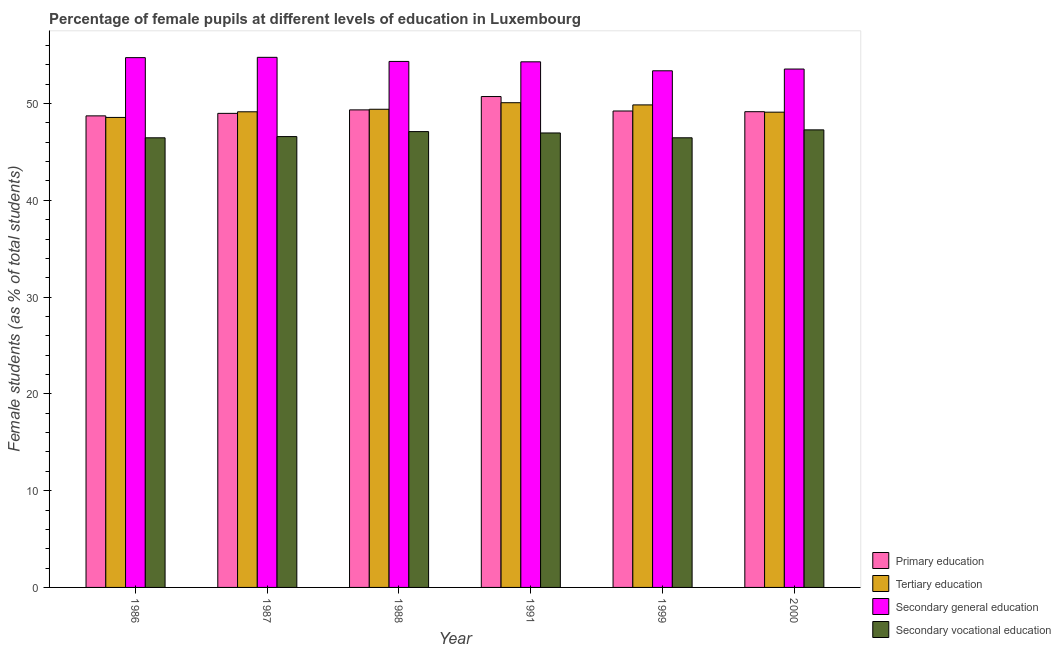Are the number of bars on each tick of the X-axis equal?
Provide a succinct answer. Yes. How many bars are there on the 5th tick from the left?
Your answer should be compact. 4. What is the label of the 3rd group of bars from the left?
Ensure brevity in your answer.  1988. What is the percentage of female students in primary education in 2000?
Keep it short and to the point. 49.16. Across all years, what is the maximum percentage of female students in tertiary education?
Ensure brevity in your answer.  50.08. Across all years, what is the minimum percentage of female students in secondary education?
Provide a succinct answer. 53.38. What is the total percentage of female students in secondary education in the graph?
Give a very brief answer. 325.12. What is the difference between the percentage of female students in primary education in 1988 and that in 2000?
Give a very brief answer. 0.19. What is the difference between the percentage of female students in secondary vocational education in 1986 and the percentage of female students in tertiary education in 1999?
Provide a short and direct response. -0. What is the average percentage of female students in secondary education per year?
Offer a very short reply. 54.19. In the year 1986, what is the difference between the percentage of female students in secondary vocational education and percentage of female students in tertiary education?
Make the answer very short. 0. What is the ratio of the percentage of female students in tertiary education in 1986 to that in 1991?
Provide a succinct answer. 0.97. What is the difference between the highest and the second highest percentage of female students in tertiary education?
Provide a succinct answer. 0.23. What is the difference between the highest and the lowest percentage of female students in secondary education?
Offer a very short reply. 1.39. In how many years, is the percentage of female students in secondary vocational education greater than the average percentage of female students in secondary vocational education taken over all years?
Give a very brief answer. 3. What does the 4th bar from the left in 1991 represents?
Make the answer very short. Secondary vocational education. What does the 3rd bar from the right in 1999 represents?
Make the answer very short. Tertiary education. Are all the bars in the graph horizontal?
Offer a very short reply. No. Does the graph contain any zero values?
Provide a succinct answer. No. Does the graph contain grids?
Offer a terse response. No. Where does the legend appear in the graph?
Provide a short and direct response. Bottom right. How many legend labels are there?
Your response must be concise. 4. What is the title of the graph?
Your answer should be compact. Percentage of female pupils at different levels of education in Luxembourg. What is the label or title of the X-axis?
Keep it short and to the point. Year. What is the label or title of the Y-axis?
Provide a short and direct response. Female students (as % of total students). What is the Female students (as % of total students) of Primary education in 1986?
Make the answer very short. 48.73. What is the Female students (as % of total students) in Tertiary education in 1986?
Your answer should be compact. 48.56. What is the Female students (as % of total students) of Secondary general education in 1986?
Give a very brief answer. 54.74. What is the Female students (as % of total students) in Secondary vocational education in 1986?
Make the answer very short. 46.46. What is the Female students (as % of total students) of Primary education in 1987?
Provide a succinct answer. 48.98. What is the Female students (as % of total students) of Tertiary education in 1987?
Provide a short and direct response. 49.15. What is the Female students (as % of total students) of Secondary general education in 1987?
Your answer should be very brief. 54.77. What is the Female students (as % of total students) in Secondary vocational education in 1987?
Make the answer very short. 46.58. What is the Female students (as % of total students) of Primary education in 1988?
Provide a succinct answer. 49.34. What is the Female students (as % of total students) in Tertiary education in 1988?
Your response must be concise. 49.41. What is the Female students (as % of total students) of Secondary general education in 1988?
Keep it short and to the point. 54.35. What is the Female students (as % of total students) in Secondary vocational education in 1988?
Offer a very short reply. 47.1. What is the Female students (as % of total students) in Primary education in 1991?
Your response must be concise. 50.72. What is the Female students (as % of total students) in Tertiary education in 1991?
Your response must be concise. 50.08. What is the Female students (as % of total students) of Secondary general education in 1991?
Your response must be concise. 54.31. What is the Female students (as % of total students) in Secondary vocational education in 1991?
Provide a short and direct response. 46.96. What is the Female students (as % of total students) of Primary education in 1999?
Your response must be concise. 49.23. What is the Female students (as % of total students) in Tertiary education in 1999?
Your response must be concise. 49.86. What is the Female students (as % of total students) in Secondary general education in 1999?
Provide a short and direct response. 53.38. What is the Female students (as % of total students) of Secondary vocational education in 1999?
Provide a short and direct response. 46.46. What is the Female students (as % of total students) of Primary education in 2000?
Your answer should be very brief. 49.16. What is the Female students (as % of total students) of Tertiary education in 2000?
Provide a short and direct response. 49.11. What is the Female students (as % of total students) of Secondary general education in 2000?
Provide a short and direct response. 53.56. What is the Female students (as % of total students) of Secondary vocational education in 2000?
Your answer should be very brief. 47.28. Across all years, what is the maximum Female students (as % of total students) of Primary education?
Provide a succinct answer. 50.72. Across all years, what is the maximum Female students (as % of total students) in Tertiary education?
Your answer should be very brief. 50.08. Across all years, what is the maximum Female students (as % of total students) of Secondary general education?
Give a very brief answer. 54.77. Across all years, what is the maximum Female students (as % of total students) in Secondary vocational education?
Your answer should be very brief. 47.28. Across all years, what is the minimum Female students (as % of total students) of Primary education?
Your answer should be compact. 48.73. Across all years, what is the minimum Female students (as % of total students) in Tertiary education?
Your response must be concise. 48.56. Across all years, what is the minimum Female students (as % of total students) of Secondary general education?
Offer a terse response. 53.38. Across all years, what is the minimum Female students (as % of total students) of Secondary vocational education?
Ensure brevity in your answer.  46.46. What is the total Female students (as % of total students) of Primary education in the graph?
Provide a succinct answer. 296.16. What is the total Female students (as % of total students) in Tertiary education in the graph?
Provide a short and direct response. 296.17. What is the total Female students (as % of total students) in Secondary general education in the graph?
Offer a very short reply. 325.12. What is the total Female students (as % of total students) of Secondary vocational education in the graph?
Provide a succinct answer. 280.84. What is the difference between the Female students (as % of total students) in Primary education in 1986 and that in 1987?
Make the answer very short. -0.26. What is the difference between the Female students (as % of total students) in Tertiary education in 1986 and that in 1987?
Give a very brief answer. -0.58. What is the difference between the Female students (as % of total students) in Secondary general education in 1986 and that in 1987?
Your answer should be very brief. -0.03. What is the difference between the Female students (as % of total students) of Secondary vocational education in 1986 and that in 1987?
Offer a very short reply. -0.13. What is the difference between the Female students (as % of total students) of Primary education in 1986 and that in 1988?
Keep it short and to the point. -0.62. What is the difference between the Female students (as % of total students) of Tertiary education in 1986 and that in 1988?
Your answer should be compact. -0.84. What is the difference between the Female students (as % of total students) of Secondary general education in 1986 and that in 1988?
Ensure brevity in your answer.  0.39. What is the difference between the Female students (as % of total students) in Secondary vocational education in 1986 and that in 1988?
Keep it short and to the point. -0.64. What is the difference between the Female students (as % of total students) in Primary education in 1986 and that in 1991?
Provide a succinct answer. -2. What is the difference between the Female students (as % of total students) of Tertiary education in 1986 and that in 1991?
Your response must be concise. -1.52. What is the difference between the Female students (as % of total students) in Secondary general education in 1986 and that in 1991?
Keep it short and to the point. 0.43. What is the difference between the Female students (as % of total students) in Secondary vocational education in 1986 and that in 1991?
Your answer should be very brief. -0.5. What is the difference between the Female students (as % of total students) in Primary education in 1986 and that in 1999?
Your answer should be very brief. -0.5. What is the difference between the Female students (as % of total students) in Tertiary education in 1986 and that in 1999?
Provide a succinct answer. -1.29. What is the difference between the Female students (as % of total students) in Secondary general education in 1986 and that in 1999?
Offer a very short reply. 1.36. What is the difference between the Female students (as % of total students) of Secondary vocational education in 1986 and that in 1999?
Make the answer very short. -0. What is the difference between the Female students (as % of total students) of Primary education in 1986 and that in 2000?
Ensure brevity in your answer.  -0.43. What is the difference between the Female students (as % of total students) of Tertiary education in 1986 and that in 2000?
Offer a terse response. -0.55. What is the difference between the Female students (as % of total students) in Secondary general education in 1986 and that in 2000?
Offer a very short reply. 1.18. What is the difference between the Female students (as % of total students) of Secondary vocational education in 1986 and that in 2000?
Offer a very short reply. -0.82. What is the difference between the Female students (as % of total students) in Primary education in 1987 and that in 1988?
Provide a succinct answer. -0.36. What is the difference between the Female students (as % of total students) of Tertiary education in 1987 and that in 1988?
Ensure brevity in your answer.  -0.26. What is the difference between the Female students (as % of total students) in Secondary general education in 1987 and that in 1988?
Your answer should be very brief. 0.42. What is the difference between the Female students (as % of total students) in Secondary vocational education in 1987 and that in 1988?
Provide a succinct answer. -0.51. What is the difference between the Female students (as % of total students) of Primary education in 1987 and that in 1991?
Your response must be concise. -1.74. What is the difference between the Female students (as % of total students) of Tertiary education in 1987 and that in 1991?
Provide a succinct answer. -0.94. What is the difference between the Female students (as % of total students) of Secondary general education in 1987 and that in 1991?
Make the answer very short. 0.46. What is the difference between the Female students (as % of total students) in Secondary vocational education in 1987 and that in 1991?
Ensure brevity in your answer.  -0.37. What is the difference between the Female students (as % of total students) in Primary education in 1987 and that in 1999?
Ensure brevity in your answer.  -0.25. What is the difference between the Female students (as % of total students) of Tertiary education in 1987 and that in 1999?
Your answer should be very brief. -0.71. What is the difference between the Female students (as % of total students) of Secondary general education in 1987 and that in 1999?
Provide a short and direct response. 1.39. What is the difference between the Female students (as % of total students) in Secondary vocational education in 1987 and that in 1999?
Your answer should be compact. 0.12. What is the difference between the Female students (as % of total students) in Primary education in 1987 and that in 2000?
Your answer should be compact. -0.17. What is the difference between the Female students (as % of total students) in Tertiary education in 1987 and that in 2000?
Provide a short and direct response. 0.04. What is the difference between the Female students (as % of total students) in Secondary general education in 1987 and that in 2000?
Your answer should be compact. 1.21. What is the difference between the Female students (as % of total students) in Secondary vocational education in 1987 and that in 2000?
Offer a very short reply. -0.69. What is the difference between the Female students (as % of total students) of Primary education in 1988 and that in 1991?
Your response must be concise. -1.38. What is the difference between the Female students (as % of total students) in Tertiary education in 1988 and that in 1991?
Make the answer very short. -0.68. What is the difference between the Female students (as % of total students) in Secondary general education in 1988 and that in 1991?
Offer a very short reply. 0.04. What is the difference between the Female students (as % of total students) in Secondary vocational education in 1988 and that in 1991?
Your answer should be compact. 0.14. What is the difference between the Female students (as % of total students) in Primary education in 1988 and that in 1999?
Offer a very short reply. 0.11. What is the difference between the Female students (as % of total students) of Tertiary education in 1988 and that in 1999?
Give a very brief answer. -0.45. What is the difference between the Female students (as % of total students) of Secondary general education in 1988 and that in 1999?
Your answer should be compact. 0.97. What is the difference between the Female students (as % of total students) of Secondary vocational education in 1988 and that in 1999?
Provide a short and direct response. 0.64. What is the difference between the Female students (as % of total students) in Primary education in 1988 and that in 2000?
Keep it short and to the point. 0.19. What is the difference between the Female students (as % of total students) in Tertiary education in 1988 and that in 2000?
Your answer should be very brief. 0.3. What is the difference between the Female students (as % of total students) of Secondary general education in 1988 and that in 2000?
Your answer should be very brief. 0.79. What is the difference between the Female students (as % of total students) in Secondary vocational education in 1988 and that in 2000?
Ensure brevity in your answer.  -0.18. What is the difference between the Female students (as % of total students) of Primary education in 1991 and that in 1999?
Offer a very short reply. 1.49. What is the difference between the Female students (as % of total students) in Tertiary education in 1991 and that in 1999?
Provide a short and direct response. 0.23. What is the difference between the Female students (as % of total students) of Secondary general education in 1991 and that in 1999?
Keep it short and to the point. 0.93. What is the difference between the Female students (as % of total students) of Secondary vocational education in 1991 and that in 1999?
Offer a terse response. 0.5. What is the difference between the Female students (as % of total students) in Primary education in 1991 and that in 2000?
Your answer should be compact. 1.57. What is the difference between the Female students (as % of total students) of Tertiary education in 1991 and that in 2000?
Offer a terse response. 0.98. What is the difference between the Female students (as % of total students) in Secondary general education in 1991 and that in 2000?
Offer a terse response. 0.75. What is the difference between the Female students (as % of total students) of Secondary vocational education in 1991 and that in 2000?
Provide a succinct answer. -0.32. What is the difference between the Female students (as % of total students) in Primary education in 1999 and that in 2000?
Your answer should be very brief. 0.07. What is the difference between the Female students (as % of total students) of Tertiary education in 1999 and that in 2000?
Offer a terse response. 0.75. What is the difference between the Female students (as % of total students) of Secondary general education in 1999 and that in 2000?
Provide a succinct answer. -0.18. What is the difference between the Female students (as % of total students) in Secondary vocational education in 1999 and that in 2000?
Provide a succinct answer. -0.82. What is the difference between the Female students (as % of total students) of Primary education in 1986 and the Female students (as % of total students) of Tertiary education in 1987?
Your answer should be very brief. -0.42. What is the difference between the Female students (as % of total students) in Primary education in 1986 and the Female students (as % of total students) in Secondary general education in 1987?
Provide a short and direct response. -6.05. What is the difference between the Female students (as % of total students) of Primary education in 1986 and the Female students (as % of total students) of Secondary vocational education in 1987?
Your answer should be very brief. 2.14. What is the difference between the Female students (as % of total students) of Tertiary education in 1986 and the Female students (as % of total students) of Secondary general education in 1987?
Provide a short and direct response. -6.21. What is the difference between the Female students (as % of total students) in Tertiary education in 1986 and the Female students (as % of total students) in Secondary vocational education in 1987?
Your answer should be very brief. 1.98. What is the difference between the Female students (as % of total students) of Secondary general education in 1986 and the Female students (as % of total students) of Secondary vocational education in 1987?
Keep it short and to the point. 8.16. What is the difference between the Female students (as % of total students) in Primary education in 1986 and the Female students (as % of total students) in Tertiary education in 1988?
Offer a terse response. -0.68. What is the difference between the Female students (as % of total students) in Primary education in 1986 and the Female students (as % of total students) in Secondary general education in 1988?
Offer a terse response. -5.62. What is the difference between the Female students (as % of total students) in Primary education in 1986 and the Female students (as % of total students) in Secondary vocational education in 1988?
Make the answer very short. 1.63. What is the difference between the Female students (as % of total students) of Tertiary education in 1986 and the Female students (as % of total students) of Secondary general education in 1988?
Keep it short and to the point. -5.79. What is the difference between the Female students (as % of total students) in Tertiary education in 1986 and the Female students (as % of total students) in Secondary vocational education in 1988?
Keep it short and to the point. 1.46. What is the difference between the Female students (as % of total students) of Secondary general education in 1986 and the Female students (as % of total students) of Secondary vocational education in 1988?
Keep it short and to the point. 7.64. What is the difference between the Female students (as % of total students) of Primary education in 1986 and the Female students (as % of total students) of Tertiary education in 1991?
Give a very brief answer. -1.36. What is the difference between the Female students (as % of total students) in Primary education in 1986 and the Female students (as % of total students) in Secondary general education in 1991?
Ensure brevity in your answer.  -5.58. What is the difference between the Female students (as % of total students) of Primary education in 1986 and the Female students (as % of total students) of Secondary vocational education in 1991?
Give a very brief answer. 1.77. What is the difference between the Female students (as % of total students) of Tertiary education in 1986 and the Female students (as % of total students) of Secondary general education in 1991?
Provide a succinct answer. -5.75. What is the difference between the Female students (as % of total students) in Tertiary education in 1986 and the Female students (as % of total students) in Secondary vocational education in 1991?
Offer a terse response. 1.6. What is the difference between the Female students (as % of total students) of Secondary general education in 1986 and the Female students (as % of total students) of Secondary vocational education in 1991?
Offer a very short reply. 7.78. What is the difference between the Female students (as % of total students) of Primary education in 1986 and the Female students (as % of total students) of Tertiary education in 1999?
Provide a succinct answer. -1.13. What is the difference between the Female students (as % of total students) in Primary education in 1986 and the Female students (as % of total students) in Secondary general education in 1999?
Ensure brevity in your answer.  -4.66. What is the difference between the Female students (as % of total students) of Primary education in 1986 and the Female students (as % of total students) of Secondary vocational education in 1999?
Offer a very short reply. 2.27. What is the difference between the Female students (as % of total students) of Tertiary education in 1986 and the Female students (as % of total students) of Secondary general education in 1999?
Keep it short and to the point. -4.82. What is the difference between the Female students (as % of total students) of Tertiary education in 1986 and the Female students (as % of total students) of Secondary vocational education in 1999?
Ensure brevity in your answer.  2.1. What is the difference between the Female students (as % of total students) in Secondary general education in 1986 and the Female students (as % of total students) in Secondary vocational education in 1999?
Your answer should be very brief. 8.28. What is the difference between the Female students (as % of total students) in Primary education in 1986 and the Female students (as % of total students) in Tertiary education in 2000?
Offer a terse response. -0.38. What is the difference between the Female students (as % of total students) of Primary education in 1986 and the Female students (as % of total students) of Secondary general education in 2000?
Give a very brief answer. -4.84. What is the difference between the Female students (as % of total students) of Primary education in 1986 and the Female students (as % of total students) of Secondary vocational education in 2000?
Your response must be concise. 1.45. What is the difference between the Female students (as % of total students) in Tertiary education in 1986 and the Female students (as % of total students) in Secondary general education in 2000?
Your answer should be very brief. -5. What is the difference between the Female students (as % of total students) of Tertiary education in 1986 and the Female students (as % of total students) of Secondary vocational education in 2000?
Give a very brief answer. 1.28. What is the difference between the Female students (as % of total students) of Secondary general education in 1986 and the Female students (as % of total students) of Secondary vocational education in 2000?
Ensure brevity in your answer.  7.46. What is the difference between the Female students (as % of total students) in Primary education in 1987 and the Female students (as % of total students) in Tertiary education in 1988?
Your response must be concise. -0.42. What is the difference between the Female students (as % of total students) in Primary education in 1987 and the Female students (as % of total students) in Secondary general education in 1988?
Offer a terse response. -5.37. What is the difference between the Female students (as % of total students) in Primary education in 1987 and the Female students (as % of total students) in Secondary vocational education in 1988?
Your answer should be very brief. 1.88. What is the difference between the Female students (as % of total students) of Tertiary education in 1987 and the Female students (as % of total students) of Secondary general education in 1988?
Your answer should be very brief. -5.2. What is the difference between the Female students (as % of total students) of Tertiary education in 1987 and the Female students (as % of total students) of Secondary vocational education in 1988?
Make the answer very short. 2.05. What is the difference between the Female students (as % of total students) in Secondary general education in 1987 and the Female students (as % of total students) in Secondary vocational education in 1988?
Your answer should be compact. 7.67. What is the difference between the Female students (as % of total students) of Primary education in 1987 and the Female students (as % of total students) of Tertiary education in 1991?
Ensure brevity in your answer.  -1.1. What is the difference between the Female students (as % of total students) in Primary education in 1987 and the Female students (as % of total students) in Secondary general education in 1991?
Ensure brevity in your answer.  -5.33. What is the difference between the Female students (as % of total students) of Primary education in 1987 and the Female students (as % of total students) of Secondary vocational education in 1991?
Your answer should be very brief. 2.02. What is the difference between the Female students (as % of total students) of Tertiary education in 1987 and the Female students (as % of total students) of Secondary general education in 1991?
Make the answer very short. -5.16. What is the difference between the Female students (as % of total students) in Tertiary education in 1987 and the Female students (as % of total students) in Secondary vocational education in 1991?
Offer a very short reply. 2.19. What is the difference between the Female students (as % of total students) in Secondary general education in 1987 and the Female students (as % of total students) in Secondary vocational education in 1991?
Your answer should be very brief. 7.81. What is the difference between the Female students (as % of total students) of Primary education in 1987 and the Female students (as % of total students) of Tertiary education in 1999?
Your answer should be very brief. -0.88. What is the difference between the Female students (as % of total students) in Primary education in 1987 and the Female students (as % of total students) in Secondary general education in 1999?
Keep it short and to the point. -4.4. What is the difference between the Female students (as % of total students) of Primary education in 1987 and the Female students (as % of total students) of Secondary vocational education in 1999?
Your response must be concise. 2.52. What is the difference between the Female students (as % of total students) in Tertiary education in 1987 and the Female students (as % of total students) in Secondary general education in 1999?
Provide a short and direct response. -4.24. What is the difference between the Female students (as % of total students) in Tertiary education in 1987 and the Female students (as % of total students) in Secondary vocational education in 1999?
Your response must be concise. 2.69. What is the difference between the Female students (as % of total students) of Secondary general education in 1987 and the Female students (as % of total students) of Secondary vocational education in 1999?
Your answer should be compact. 8.31. What is the difference between the Female students (as % of total students) in Primary education in 1987 and the Female students (as % of total students) in Tertiary education in 2000?
Make the answer very short. -0.13. What is the difference between the Female students (as % of total students) of Primary education in 1987 and the Female students (as % of total students) of Secondary general education in 2000?
Ensure brevity in your answer.  -4.58. What is the difference between the Female students (as % of total students) in Primary education in 1987 and the Female students (as % of total students) in Secondary vocational education in 2000?
Your answer should be very brief. 1.7. What is the difference between the Female students (as % of total students) in Tertiary education in 1987 and the Female students (as % of total students) in Secondary general education in 2000?
Your answer should be compact. -4.42. What is the difference between the Female students (as % of total students) of Tertiary education in 1987 and the Female students (as % of total students) of Secondary vocational education in 2000?
Offer a terse response. 1.87. What is the difference between the Female students (as % of total students) of Secondary general education in 1987 and the Female students (as % of total students) of Secondary vocational education in 2000?
Offer a very short reply. 7.5. What is the difference between the Female students (as % of total students) in Primary education in 1988 and the Female students (as % of total students) in Tertiary education in 1991?
Your response must be concise. -0.74. What is the difference between the Female students (as % of total students) of Primary education in 1988 and the Female students (as % of total students) of Secondary general education in 1991?
Your response must be concise. -4.96. What is the difference between the Female students (as % of total students) of Primary education in 1988 and the Female students (as % of total students) of Secondary vocational education in 1991?
Ensure brevity in your answer.  2.39. What is the difference between the Female students (as % of total students) in Tertiary education in 1988 and the Female students (as % of total students) in Secondary general education in 1991?
Provide a short and direct response. -4.9. What is the difference between the Female students (as % of total students) in Tertiary education in 1988 and the Female students (as % of total students) in Secondary vocational education in 1991?
Provide a short and direct response. 2.45. What is the difference between the Female students (as % of total students) in Secondary general education in 1988 and the Female students (as % of total students) in Secondary vocational education in 1991?
Ensure brevity in your answer.  7.39. What is the difference between the Female students (as % of total students) of Primary education in 1988 and the Female students (as % of total students) of Tertiary education in 1999?
Keep it short and to the point. -0.51. What is the difference between the Female students (as % of total students) of Primary education in 1988 and the Female students (as % of total students) of Secondary general education in 1999?
Offer a very short reply. -4.04. What is the difference between the Female students (as % of total students) of Primary education in 1988 and the Female students (as % of total students) of Secondary vocational education in 1999?
Keep it short and to the point. 2.88. What is the difference between the Female students (as % of total students) in Tertiary education in 1988 and the Female students (as % of total students) in Secondary general education in 1999?
Your answer should be compact. -3.97. What is the difference between the Female students (as % of total students) of Tertiary education in 1988 and the Female students (as % of total students) of Secondary vocational education in 1999?
Your answer should be very brief. 2.95. What is the difference between the Female students (as % of total students) of Secondary general education in 1988 and the Female students (as % of total students) of Secondary vocational education in 1999?
Your response must be concise. 7.89. What is the difference between the Female students (as % of total students) in Primary education in 1988 and the Female students (as % of total students) in Tertiary education in 2000?
Provide a short and direct response. 0.24. What is the difference between the Female students (as % of total students) of Primary education in 1988 and the Female students (as % of total students) of Secondary general education in 2000?
Make the answer very short. -4.22. What is the difference between the Female students (as % of total students) of Primary education in 1988 and the Female students (as % of total students) of Secondary vocational education in 2000?
Offer a very short reply. 2.07. What is the difference between the Female students (as % of total students) of Tertiary education in 1988 and the Female students (as % of total students) of Secondary general education in 2000?
Keep it short and to the point. -4.16. What is the difference between the Female students (as % of total students) in Tertiary education in 1988 and the Female students (as % of total students) in Secondary vocational education in 2000?
Your answer should be compact. 2.13. What is the difference between the Female students (as % of total students) of Secondary general education in 1988 and the Female students (as % of total students) of Secondary vocational education in 2000?
Provide a short and direct response. 7.07. What is the difference between the Female students (as % of total students) of Primary education in 1991 and the Female students (as % of total students) of Tertiary education in 1999?
Keep it short and to the point. 0.86. What is the difference between the Female students (as % of total students) in Primary education in 1991 and the Female students (as % of total students) in Secondary general education in 1999?
Offer a terse response. -2.66. What is the difference between the Female students (as % of total students) of Primary education in 1991 and the Female students (as % of total students) of Secondary vocational education in 1999?
Ensure brevity in your answer.  4.26. What is the difference between the Female students (as % of total students) in Tertiary education in 1991 and the Female students (as % of total students) in Secondary general education in 1999?
Your answer should be compact. -3.3. What is the difference between the Female students (as % of total students) in Tertiary education in 1991 and the Female students (as % of total students) in Secondary vocational education in 1999?
Provide a short and direct response. 3.62. What is the difference between the Female students (as % of total students) in Secondary general education in 1991 and the Female students (as % of total students) in Secondary vocational education in 1999?
Provide a succinct answer. 7.85. What is the difference between the Female students (as % of total students) of Primary education in 1991 and the Female students (as % of total students) of Tertiary education in 2000?
Your response must be concise. 1.61. What is the difference between the Female students (as % of total students) of Primary education in 1991 and the Female students (as % of total students) of Secondary general education in 2000?
Your response must be concise. -2.84. What is the difference between the Female students (as % of total students) in Primary education in 1991 and the Female students (as % of total students) in Secondary vocational education in 2000?
Make the answer very short. 3.44. What is the difference between the Female students (as % of total students) in Tertiary education in 1991 and the Female students (as % of total students) in Secondary general education in 2000?
Give a very brief answer. -3.48. What is the difference between the Female students (as % of total students) in Tertiary education in 1991 and the Female students (as % of total students) in Secondary vocational education in 2000?
Keep it short and to the point. 2.81. What is the difference between the Female students (as % of total students) in Secondary general education in 1991 and the Female students (as % of total students) in Secondary vocational education in 2000?
Make the answer very short. 7.03. What is the difference between the Female students (as % of total students) of Primary education in 1999 and the Female students (as % of total students) of Tertiary education in 2000?
Make the answer very short. 0.12. What is the difference between the Female students (as % of total students) in Primary education in 1999 and the Female students (as % of total students) in Secondary general education in 2000?
Provide a short and direct response. -4.33. What is the difference between the Female students (as % of total students) of Primary education in 1999 and the Female students (as % of total students) of Secondary vocational education in 2000?
Give a very brief answer. 1.95. What is the difference between the Female students (as % of total students) in Tertiary education in 1999 and the Female students (as % of total students) in Secondary general education in 2000?
Your response must be concise. -3.71. What is the difference between the Female students (as % of total students) of Tertiary education in 1999 and the Female students (as % of total students) of Secondary vocational education in 2000?
Provide a succinct answer. 2.58. What is the difference between the Female students (as % of total students) of Secondary general education in 1999 and the Female students (as % of total students) of Secondary vocational education in 2000?
Offer a terse response. 6.1. What is the average Female students (as % of total students) of Primary education per year?
Give a very brief answer. 49.36. What is the average Female students (as % of total students) in Tertiary education per year?
Provide a succinct answer. 49.36. What is the average Female students (as % of total students) in Secondary general education per year?
Give a very brief answer. 54.19. What is the average Female students (as % of total students) in Secondary vocational education per year?
Offer a terse response. 46.81. In the year 1986, what is the difference between the Female students (as % of total students) of Primary education and Female students (as % of total students) of Tertiary education?
Make the answer very short. 0.16. In the year 1986, what is the difference between the Female students (as % of total students) in Primary education and Female students (as % of total students) in Secondary general education?
Your answer should be very brief. -6.02. In the year 1986, what is the difference between the Female students (as % of total students) of Primary education and Female students (as % of total students) of Secondary vocational education?
Give a very brief answer. 2.27. In the year 1986, what is the difference between the Female students (as % of total students) of Tertiary education and Female students (as % of total students) of Secondary general education?
Your answer should be very brief. -6.18. In the year 1986, what is the difference between the Female students (as % of total students) of Tertiary education and Female students (as % of total students) of Secondary vocational education?
Give a very brief answer. 2.11. In the year 1986, what is the difference between the Female students (as % of total students) in Secondary general education and Female students (as % of total students) in Secondary vocational education?
Your answer should be very brief. 8.28. In the year 1987, what is the difference between the Female students (as % of total students) of Primary education and Female students (as % of total students) of Tertiary education?
Your answer should be compact. -0.16. In the year 1987, what is the difference between the Female students (as % of total students) of Primary education and Female students (as % of total students) of Secondary general education?
Make the answer very short. -5.79. In the year 1987, what is the difference between the Female students (as % of total students) of Primary education and Female students (as % of total students) of Secondary vocational education?
Your answer should be compact. 2.4. In the year 1987, what is the difference between the Female students (as % of total students) of Tertiary education and Female students (as % of total students) of Secondary general education?
Your answer should be very brief. -5.63. In the year 1987, what is the difference between the Female students (as % of total students) of Tertiary education and Female students (as % of total students) of Secondary vocational education?
Give a very brief answer. 2.56. In the year 1987, what is the difference between the Female students (as % of total students) of Secondary general education and Female students (as % of total students) of Secondary vocational education?
Your answer should be compact. 8.19. In the year 1988, what is the difference between the Female students (as % of total students) in Primary education and Female students (as % of total students) in Tertiary education?
Provide a succinct answer. -0.06. In the year 1988, what is the difference between the Female students (as % of total students) of Primary education and Female students (as % of total students) of Secondary general education?
Make the answer very short. -5.01. In the year 1988, what is the difference between the Female students (as % of total students) in Primary education and Female students (as % of total students) in Secondary vocational education?
Your answer should be very brief. 2.24. In the year 1988, what is the difference between the Female students (as % of total students) of Tertiary education and Female students (as % of total students) of Secondary general education?
Provide a succinct answer. -4.94. In the year 1988, what is the difference between the Female students (as % of total students) in Tertiary education and Female students (as % of total students) in Secondary vocational education?
Your response must be concise. 2.31. In the year 1988, what is the difference between the Female students (as % of total students) in Secondary general education and Female students (as % of total students) in Secondary vocational education?
Provide a succinct answer. 7.25. In the year 1991, what is the difference between the Female students (as % of total students) in Primary education and Female students (as % of total students) in Tertiary education?
Provide a short and direct response. 0.64. In the year 1991, what is the difference between the Female students (as % of total students) of Primary education and Female students (as % of total students) of Secondary general education?
Ensure brevity in your answer.  -3.59. In the year 1991, what is the difference between the Female students (as % of total students) of Primary education and Female students (as % of total students) of Secondary vocational education?
Keep it short and to the point. 3.76. In the year 1991, what is the difference between the Female students (as % of total students) of Tertiary education and Female students (as % of total students) of Secondary general education?
Give a very brief answer. -4.22. In the year 1991, what is the difference between the Female students (as % of total students) in Tertiary education and Female students (as % of total students) in Secondary vocational education?
Offer a terse response. 3.13. In the year 1991, what is the difference between the Female students (as % of total students) in Secondary general education and Female students (as % of total students) in Secondary vocational education?
Your answer should be compact. 7.35. In the year 1999, what is the difference between the Female students (as % of total students) in Primary education and Female students (as % of total students) in Tertiary education?
Give a very brief answer. -0.63. In the year 1999, what is the difference between the Female students (as % of total students) in Primary education and Female students (as % of total students) in Secondary general education?
Make the answer very short. -4.15. In the year 1999, what is the difference between the Female students (as % of total students) of Primary education and Female students (as % of total students) of Secondary vocational education?
Keep it short and to the point. 2.77. In the year 1999, what is the difference between the Female students (as % of total students) in Tertiary education and Female students (as % of total students) in Secondary general education?
Ensure brevity in your answer.  -3.52. In the year 1999, what is the difference between the Female students (as % of total students) of Tertiary education and Female students (as % of total students) of Secondary vocational education?
Ensure brevity in your answer.  3.4. In the year 1999, what is the difference between the Female students (as % of total students) of Secondary general education and Female students (as % of total students) of Secondary vocational education?
Make the answer very short. 6.92. In the year 2000, what is the difference between the Female students (as % of total students) of Primary education and Female students (as % of total students) of Tertiary education?
Ensure brevity in your answer.  0.05. In the year 2000, what is the difference between the Female students (as % of total students) of Primary education and Female students (as % of total students) of Secondary general education?
Keep it short and to the point. -4.41. In the year 2000, what is the difference between the Female students (as % of total students) of Primary education and Female students (as % of total students) of Secondary vocational education?
Your response must be concise. 1.88. In the year 2000, what is the difference between the Female students (as % of total students) in Tertiary education and Female students (as % of total students) in Secondary general education?
Offer a very short reply. -4.46. In the year 2000, what is the difference between the Female students (as % of total students) in Tertiary education and Female students (as % of total students) in Secondary vocational education?
Provide a short and direct response. 1.83. In the year 2000, what is the difference between the Female students (as % of total students) in Secondary general education and Female students (as % of total students) in Secondary vocational education?
Provide a succinct answer. 6.29. What is the ratio of the Female students (as % of total students) in Tertiary education in 1986 to that in 1987?
Provide a succinct answer. 0.99. What is the ratio of the Female students (as % of total students) in Secondary general education in 1986 to that in 1987?
Offer a terse response. 1. What is the ratio of the Female students (as % of total students) in Secondary vocational education in 1986 to that in 1987?
Ensure brevity in your answer.  1. What is the ratio of the Female students (as % of total students) in Primary education in 1986 to that in 1988?
Ensure brevity in your answer.  0.99. What is the ratio of the Female students (as % of total students) of Tertiary education in 1986 to that in 1988?
Offer a very short reply. 0.98. What is the ratio of the Female students (as % of total students) of Secondary general education in 1986 to that in 1988?
Make the answer very short. 1.01. What is the ratio of the Female students (as % of total students) of Secondary vocational education in 1986 to that in 1988?
Make the answer very short. 0.99. What is the ratio of the Female students (as % of total students) of Primary education in 1986 to that in 1991?
Provide a short and direct response. 0.96. What is the ratio of the Female students (as % of total students) in Tertiary education in 1986 to that in 1991?
Your answer should be very brief. 0.97. What is the ratio of the Female students (as % of total students) of Secondary general education in 1986 to that in 1991?
Make the answer very short. 1.01. What is the ratio of the Female students (as % of total students) in Secondary vocational education in 1986 to that in 1991?
Your response must be concise. 0.99. What is the ratio of the Female students (as % of total students) in Tertiary education in 1986 to that in 1999?
Make the answer very short. 0.97. What is the ratio of the Female students (as % of total students) of Secondary general education in 1986 to that in 1999?
Keep it short and to the point. 1.03. What is the ratio of the Female students (as % of total students) in Tertiary education in 1986 to that in 2000?
Provide a short and direct response. 0.99. What is the ratio of the Female students (as % of total students) of Secondary vocational education in 1986 to that in 2000?
Offer a very short reply. 0.98. What is the ratio of the Female students (as % of total students) in Primary education in 1987 to that in 1988?
Give a very brief answer. 0.99. What is the ratio of the Female students (as % of total students) of Tertiary education in 1987 to that in 1988?
Give a very brief answer. 0.99. What is the ratio of the Female students (as % of total students) in Secondary vocational education in 1987 to that in 1988?
Offer a very short reply. 0.99. What is the ratio of the Female students (as % of total students) in Primary education in 1987 to that in 1991?
Offer a terse response. 0.97. What is the ratio of the Female students (as % of total students) in Tertiary education in 1987 to that in 1991?
Your response must be concise. 0.98. What is the ratio of the Female students (as % of total students) in Secondary general education in 1987 to that in 1991?
Make the answer very short. 1.01. What is the ratio of the Female students (as % of total students) of Tertiary education in 1987 to that in 1999?
Keep it short and to the point. 0.99. What is the ratio of the Female students (as % of total students) in Secondary general education in 1987 to that in 1999?
Provide a short and direct response. 1.03. What is the ratio of the Female students (as % of total students) in Primary education in 1987 to that in 2000?
Offer a terse response. 1. What is the ratio of the Female students (as % of total students) in Tertiary education in 1987 to that in 2000?
Ensure brevity in your answer.  1. What is the ratio of the Female students (as % of total students) of Secondary general education in 1987 to that in 2000?
Ensure brevity in your answer.  1.02. What is the ratio of the Female students (as % of total students) of Secondary vocational education in 1987 to that in 2000?
Make the answer very short. 0.99. What is the ratio of the Female students (as % of total students) of Primary education in 1988 to that in 1991?
Keep it short and to the point. 0.97. What is the ratio of the Female students (as % of total students) of Tertiary education in 1988 to that in 1991?
Your answer should be compact. 0.99. What is the ratio of the Female students (as % of total students) in Secondary general education in 1988 to that in 1991?
Keep it short and to the point. 1. What is the ratio of the Female students (as % of total students) of Primary education in 1988 to that in 1999?
Give a very brief answer. 1. What is the ratio of the Female students (as % of total students) of Secondary general education in 1988 to that in 1999?
Offer a very short reply. 1.02. What is the ratio of the Female students (as % of total students) of Secondary vocational education in 1988 to that in 1999?
Make the answer very short. 1.01. What is the ratio of the Female students (as % of total students) of Primary education in 1988 to that in 2000?
Make the answer very short. 1. What is the ratio of the Female students (as % of total students) in Secondary general education in 1988 to that in 2000?
Give a very brief answer. 1.01. What is the ratio of the Female students (as % of total students) in Primary education in 1991 to that in 1999?
Give a very brief answer. 1.03. What is the ratio of the Female students (as % of total students) of Secondary general education in 1991 to that in 1999?
Ensure brevity in your answer.  1.02. What is the ratio of the Female students (as % of total students) of Secondary vocational education in 1991 to that in 1999?
Provide a succinct answer. 1.01. What is the ratio of the Female students (as % of total students) in Primary education in 1991 to that in 2000?
Give a very brief answer. 1.03. What is the ratio of the Female students (as % of total students) of Tertiary education in 1991 to that in 2000?
Your answer should be compact. 1.02. What is the ratio of the Female students (as % of total students) of Secondary general education in 1991 to that in 2000?
Ensure brevity in your answer.  1.01. What is the ratio of the Female students (as % of total students) in Secondary vocational education in 1991 to that in 2000?
Your response must be concise. 0.99. What is the ratio of the Female students (as % of total students) of Primary education in 1999 to that in 2000?
Offer a very short reply. 1. What is the ratio of the Female students (as % of total students) in Tertiary education in 1999 to that in 2000?
Keep it short and to the point. 1.02. What is the ratio of the Female students (as % of total students) of Secondary general education in 1999 to that in 2000?
Provide a short and direct response. 1. What is the ratio of the Female students (as % of total students) of Secondary vocational education in 1999 to that in 2000?
Provide a succinct answer. 0.98. What is the difference between the highest and the second highest Female students (as % of total students) of Primary education?
Provide a succinct answer. 1.38. What is the difference between the highest and the second highest Female students (as % of total students) in Tertiary education?
Offer a terse response. 0.23. What is the difference between the highest and the second highest Female students (as % of total students) of Secondary general education?
Ensure brevity in your answer.  0.03. What is the difference between the highest and the second highest Female students (as % of total students) in Secondary vocational education?
Your answer should be very brief. 0.18. What is the difference between the highest and the lowest Female students (as % of total students) in Primary education?
Your answer should be compact. 2. What is the difference between the highest and the lowest Female students (as % of total students) in Tertiary education?
Your response must be concise. 1.52. What is the difference between the highest and the lowest Female students (as % of total students) in Secondary general education?
Give a very brief answer. 1.39. What is the difference between the highest and the lowest Female students (as % of total students) in Secondary vocational education?
Your answer should be compact. 0.82. 